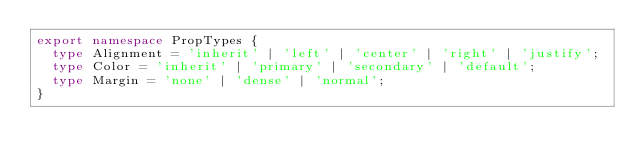Convert code to text. <code><loc_0><loc_0><loc_500><loc_500><_TypeScript_>export namespace PropTypes {
  type Alignment = 'inherit' | 'left' | 'center' | 'right' | 'justify';
  type Color = 'inherit' | 'primary' | 'secondary' | 'default';
  type Margin = 'none' | 'dense' | 'normal';
}
</code> 